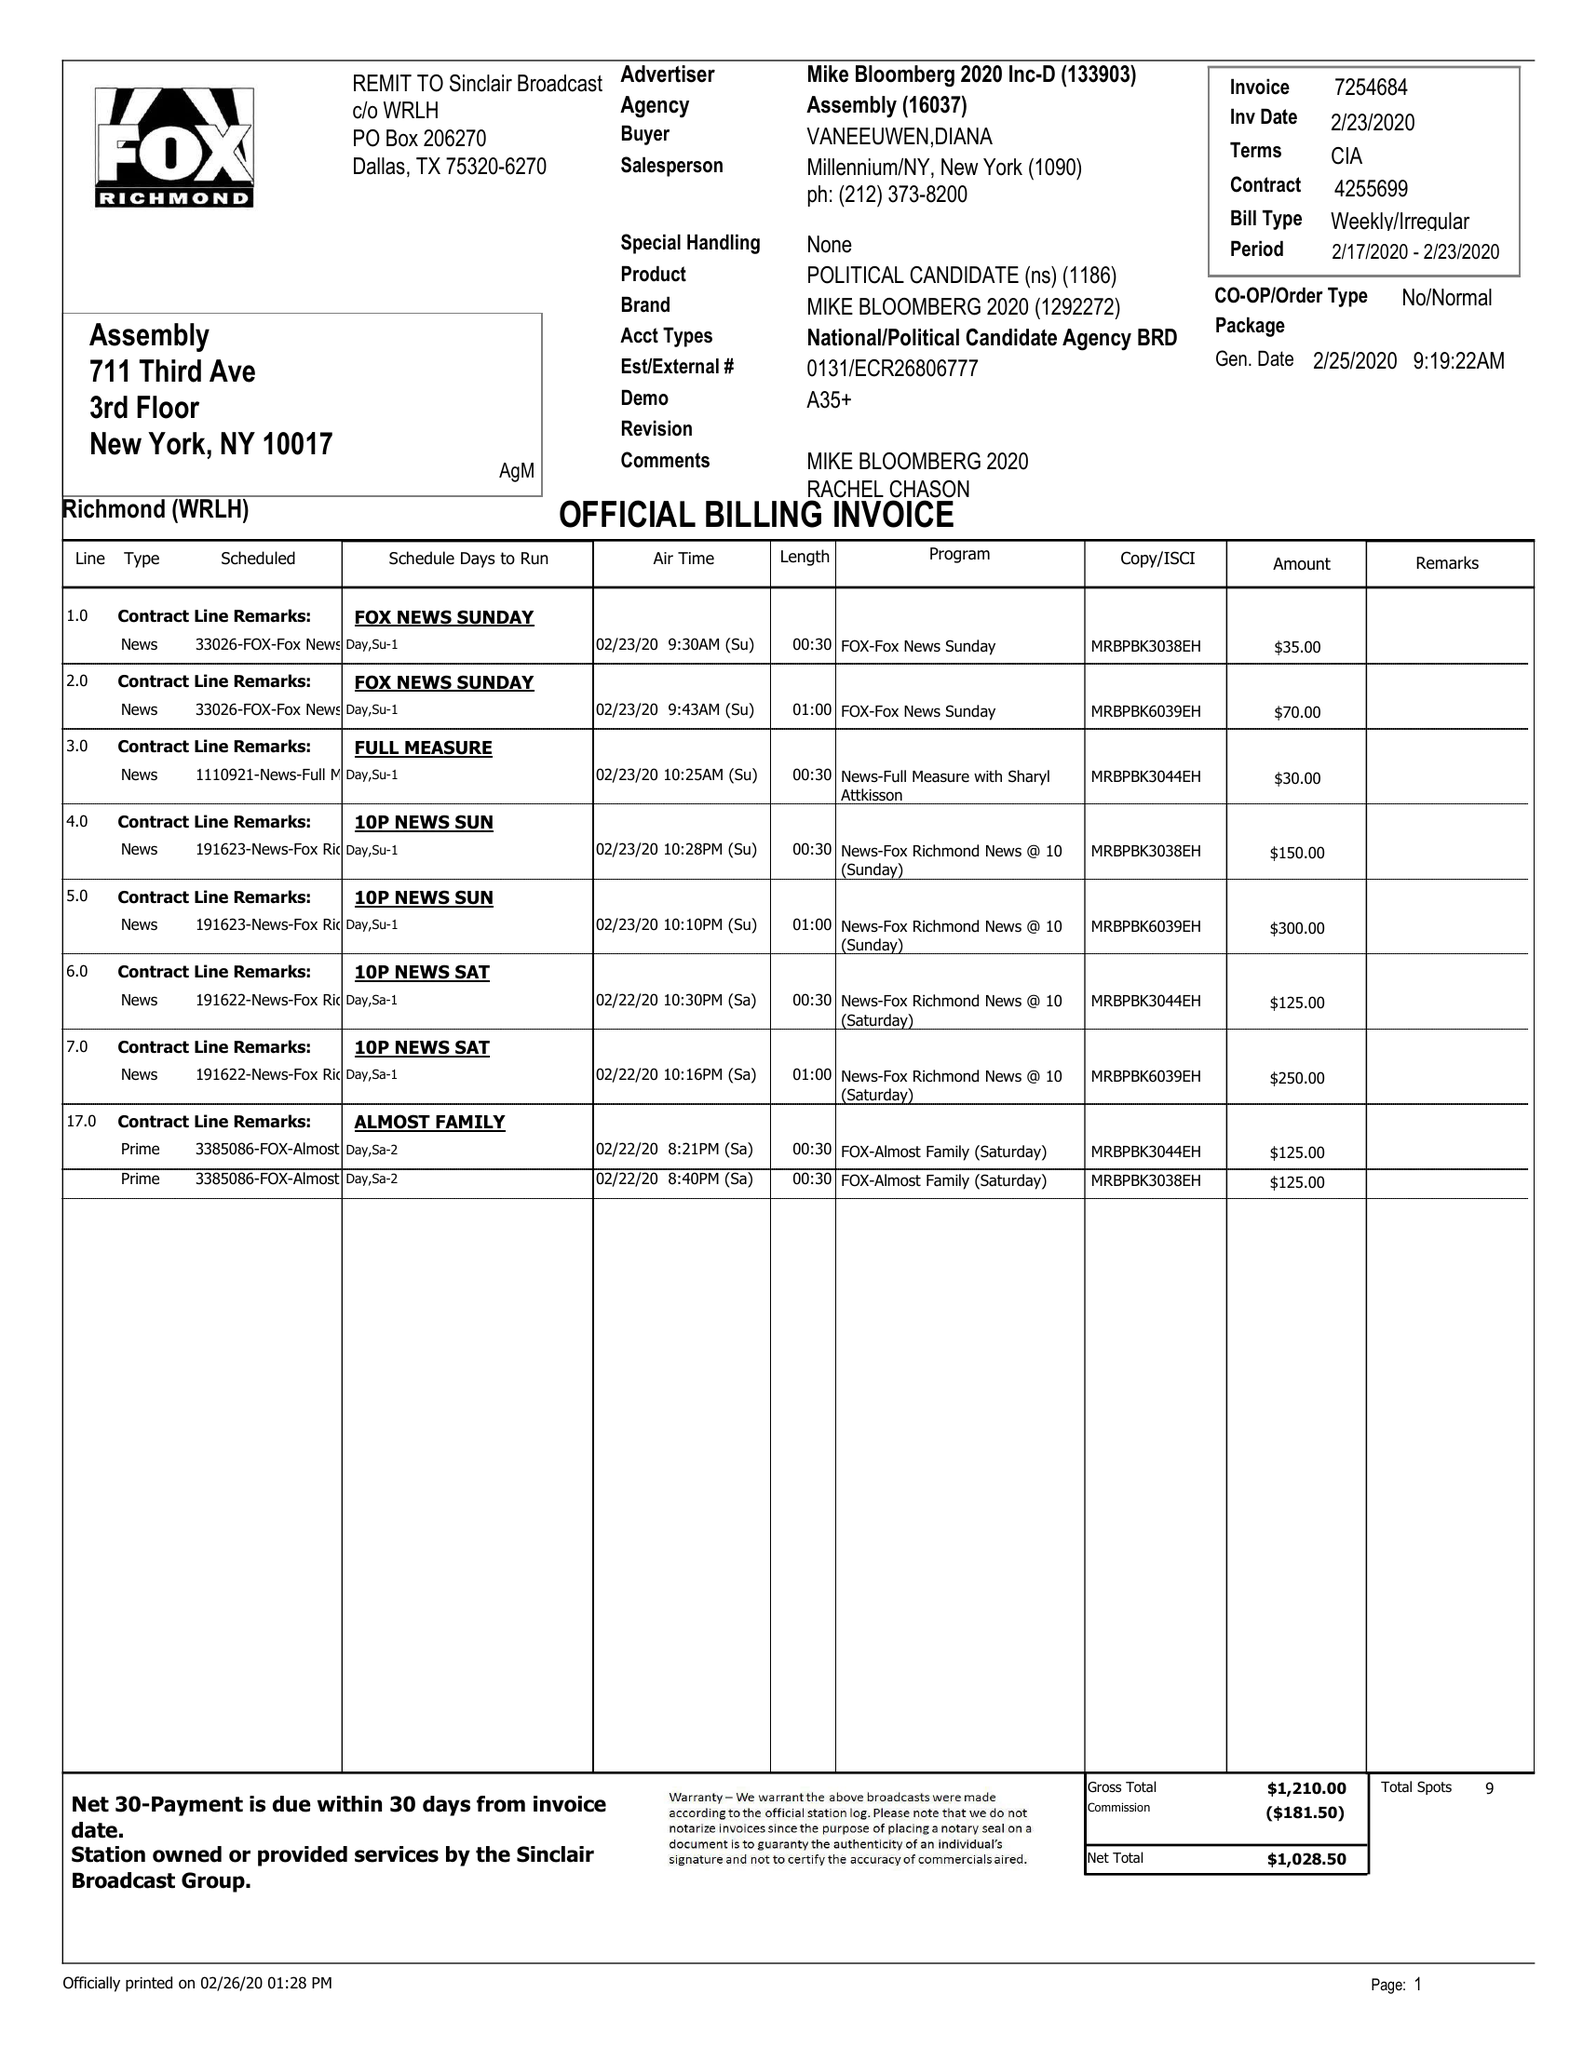What is the value for the gross_amount?
Answer the question using a single word or phrase. 1210.00 